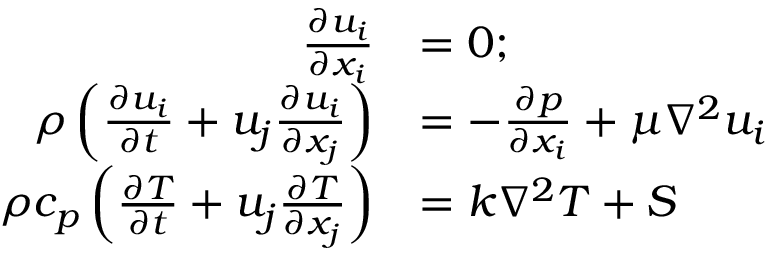<formula> <loc_0><loc_0><loc_500><loc_500>\begin{array} { r l } { \frac { \partial u _ { i } } { \partial x _ { i } } } & { = 0 ; } \\ { \rho \left ( \frac { \partial u _ { i } } { \partial t } + u _ { j } \frac { \partial u _ { i } } { \partial x _ { j } } \right ) } & { = - \frac { \partial p } { \partial x _ { i } } + \mu \nabla ^ { 2 } u _ { i } } \\ { \rho c _ { p } \left ( \frac { \partial T } { \partial t } + u _ { j } \frac { \partial T } { \partial x _ { j } } \right ) } & { = k \nabla ^ { 2 } T + S } \end{array}</formula> 